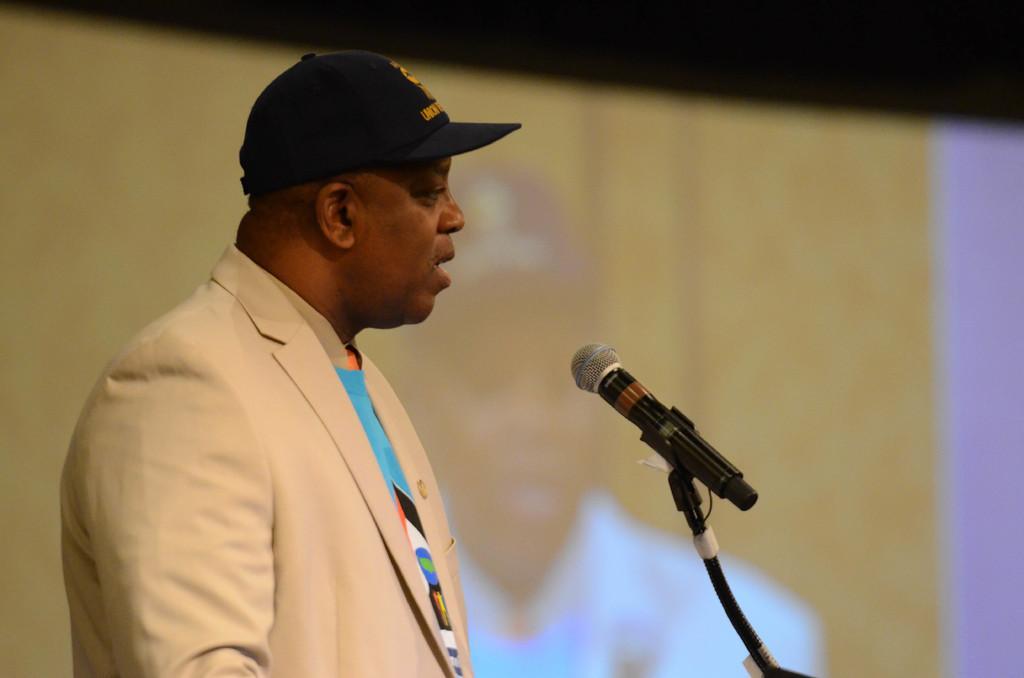Could you give a brief overview of what you see in this image? In this image I can see a man wearing black color of cap standing in front of a mic. I can see man is wearing cream color of dress. 